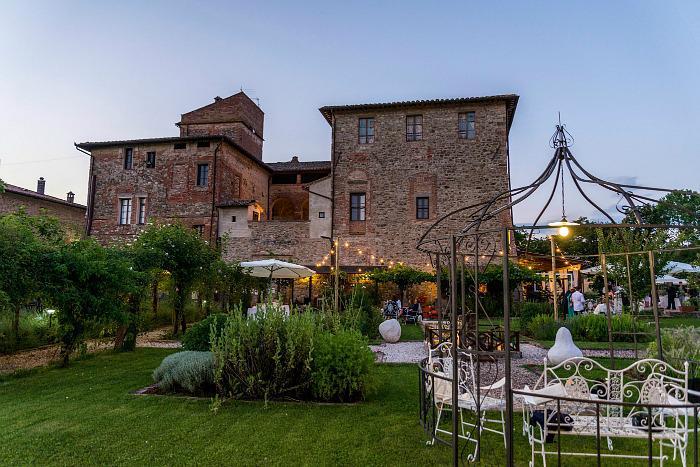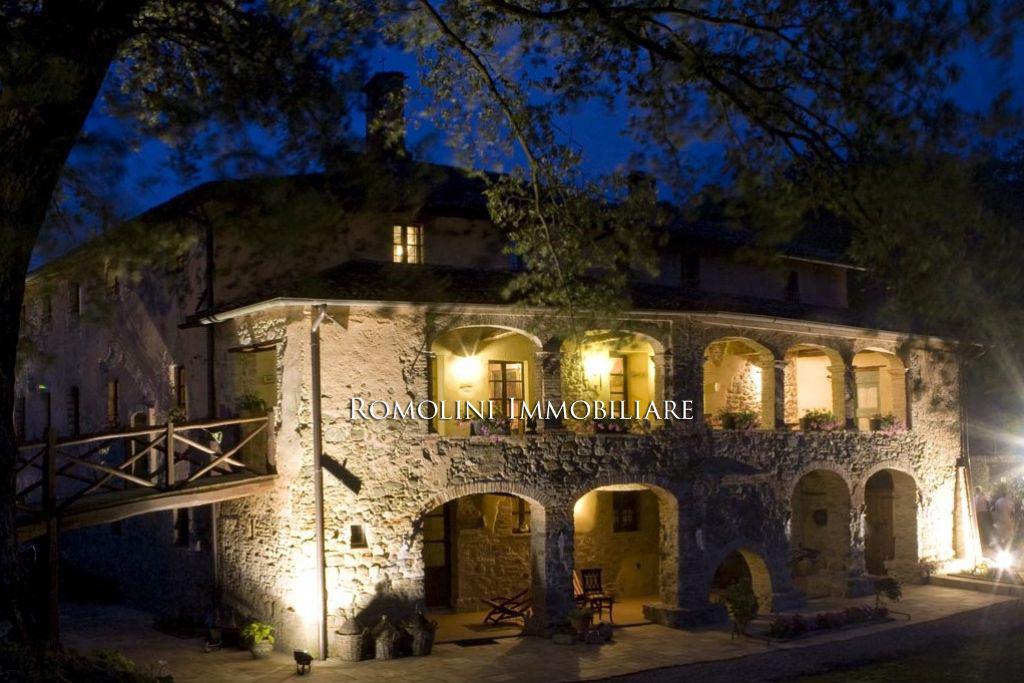The first image is the image on the left, the second image is the image on the right. For the images shown, is this caption "There is a gazebo in one of the images." true? Answer yes or no. Yes. 